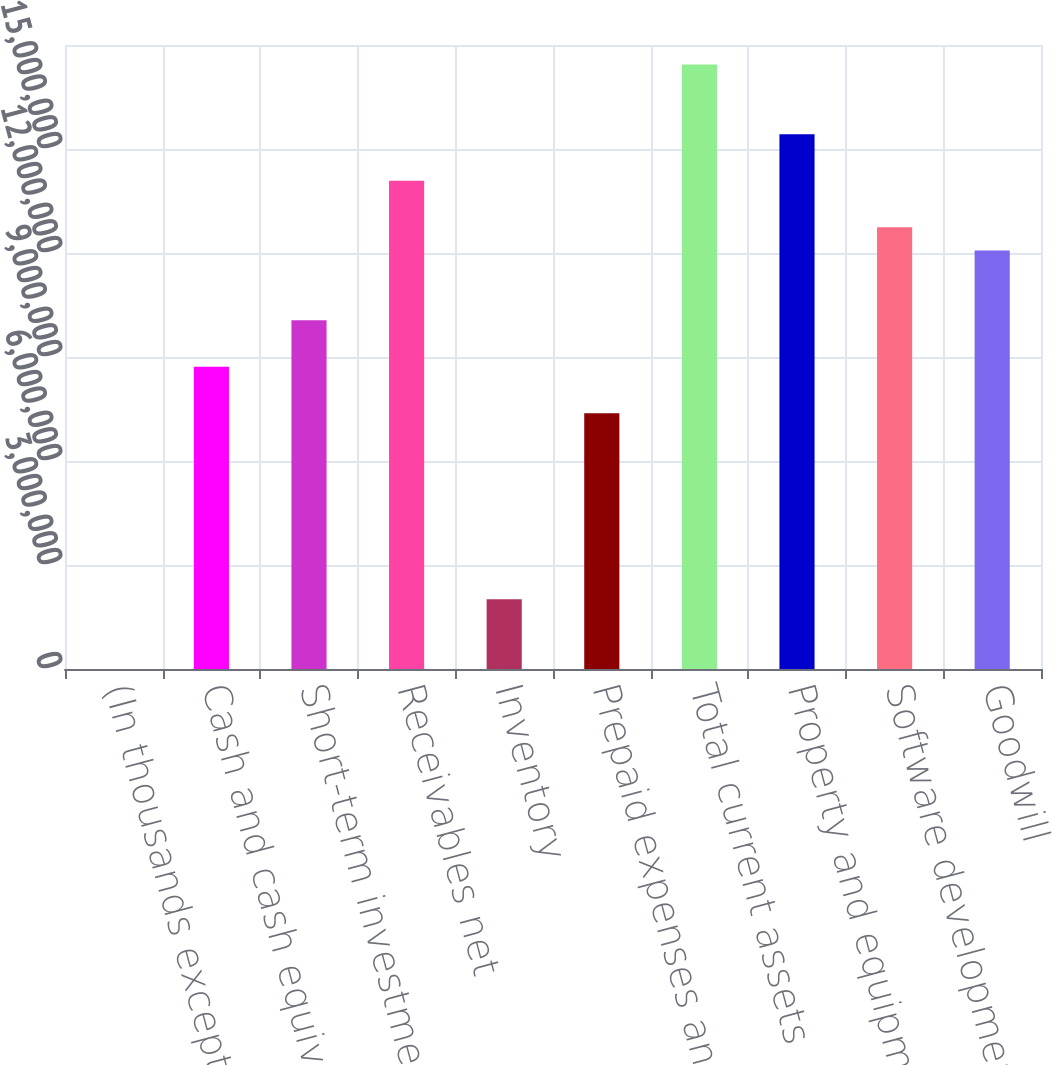Convert chart to OTSL. <chart><loc_0><loc_0><loc_500><loc_500><bar_chart><fcel>(In thousands except share<fcel>Cash and cash equivalents<fcel>Short-term investments<fcel>Receivables net<fcel>Inventory<fcel>Prepaid expenses and other<fcel>Total current assets<fcel>Property and equipment net<fcel>Software development costs net<fcel>Goodwill<nl><fcel>2018<fcel>8.72062e+06<fcel>1.00619e+07<fcel>1.40859e+07<fcel>2.014e+06<fcel>7.3793e+06<fcel>1.74392e+07<fcel>1.54272e+07<fcel>1.27446e+07<fcel>1.20739e+07<nl></chart> 